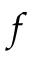Convert formula to latex. <formula><loc_0><loc_0><loc_500><loc_500>f</formula> 